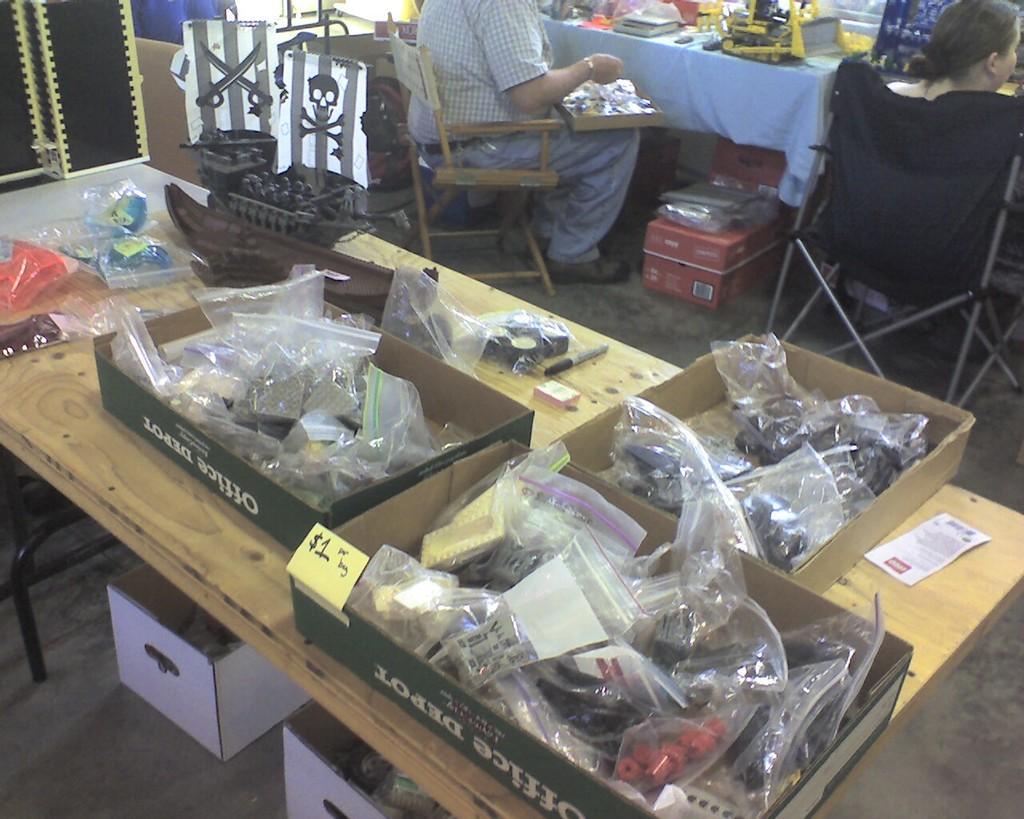Could you give a brief overview of what you see in this image? In the foreground of the picture we can see boxes, covers, table, toys looking like boats and other objects. At the top there are people, chairs, boxes and various objects. 